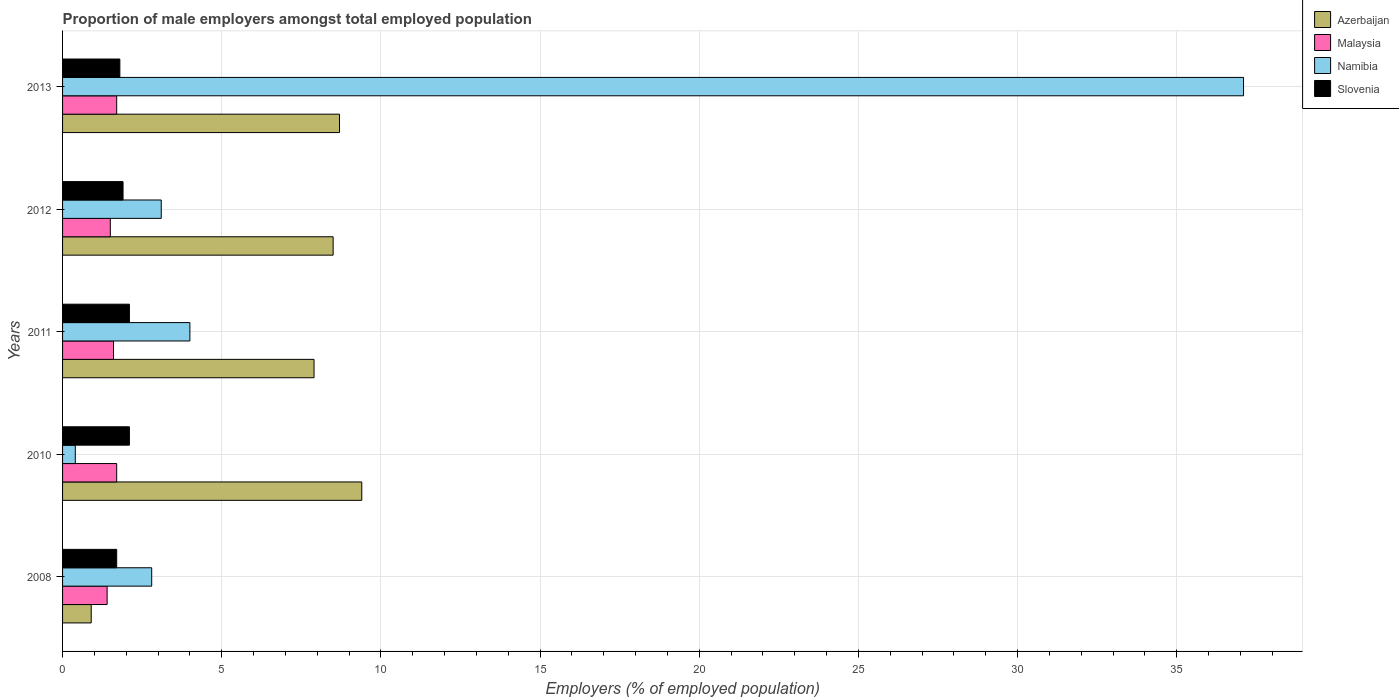How many different coloured bars are there?
Ensure brevity in your answer.  4. How many groups of bars are there?
Your response must be concise. 5. Are the number of bars per tick equal to the number of legend labels?
Give a very brief answer. Yes. How many bars are there on the 5th tick from the top?
Your answer should be very brief. 4. What is the label of the 3rd group of bars from the top?
Ensure brevity in your answer.  2011. Across all years, what is the maximum proportion of male employers in Azerbaijan?
Keep it short and to the point. 9.4. Across all years, what is the minimum proportion of male employers in Namibia?
Give a very brief answer. 0.4. In which year was the proportion of male employers in Malaysia minimum?
Offer a terse response. 2008. What is the total proportion of male employers in Azerbaijan in the graph?
Keep it short and to the point. 35.4. What is the difference between the proportion of male employers in Malaysia in 2012 and that in 2013?
Ensure brevity in your answer.  -0.2. What is the difference between the proportion of male employers in Namibia in 2010 and the proportion of male employers in Slovenia in 2008?
Offer a very short reply. -1.3. What is the average proportion of male employers in Slovenia per year?
Offer a very short reply. 1.92. In the year 2010, what is the difference between the proportion of male employers in Namibia and proportion of male employers in Slovenia?
Your answer should be compact. -1.7. In how many years, is the proportion of male employers in Slovenia greater than 17 %?
Ensure brevity in your answer.  0. What is the ratio of the proportion of male employers in Azerbaijan in 2011 to that in 2012?
Your response must be concise. 0.93. Is the proportion of male employers in Malaysia in 2010 less than that in 2013?
Your answer should be very brief. No. What is the difference between the highest and the second highest proportion of male employers in Slovenia?
Offer a very short reply. 0. What is the difference between the highest and the lowest proportion of male employers in Slovenia?
Your response must be concise. 0.4. In how many years, is the proportion of male employers in Azerbaijan greater than the average proportion of male employers in Azerbaijan taken over all years?
Give a very brief answer. 4. Is the sum of the proportion of male employers in Namibia in 2008 and 2013 greater than the maximum proportion of male employers in Azerbaijan across all years?
Offer a terse response. Yes. What does the 4th bar from the top in 2012 represents?
Offer a very short reply. Azerbaijan. What does the 4th bar from the bottom in 2013 represents?
Offer a terse response. Slovenia. Is it the case that in every year, the sum of the proportion of male employers in Slovenia and proportion of male employers in Azerbaijan is greater than the proportion of male employers in Malaysia?
Your answer should be very brief. Yes. How many bars are there?
Offer a very short reply. 20. Are all the bars in the graph horizontal?
Your response must be concise. Yes. How many years are there in the graph?
Provide a short and direct response. 5. Are the values on the major ticks of X-axis written in scientific E-notation?
Keep it short and to the point. No. Does the graph contain any zero values?
Offer a terse response. No. Does the graph contain grids?
Your answer should be compact. Yes. Where does the legend appear in the graph?
Offer a terse response. Top right. How many legend labels are there?
Offer a terse response. 4. How are the legend labels stacked?
Your response must be concise. Vertical. What is the title of the graph?
Make the answer very short. Proportion of male employers amongst total employed population. Does "Pakistan" appear as one of the legend labels in the graph?
Give a very brief answer. No. What is the label or title of the X-axis?
Your answer should be compact. Employers (% of employed population). What is the label or title of the Y-axis?
Provide a short and direct response. Years. What is the Employers (% of employed population) of Azerbaijan in 2008?
Ensure brevity in your answer.  0.9. What is the Employers (% of employed population) of Malaysia in 2008?
Offer a very short reply. 1.4. What is the Employers (% of employed population) of Namibia in 2008?
Offer a very short reply. 2.8. What is the Employers (% of employed population) of Slovenia in 2008?
Offer a terse response. 1.7. What is the Employers (% of employed population) of Azerbaijan in 2010?
Provide a succinct answer. 9.4. What is the Employers (% of employed population) of Malaysia in 2010?
Offer a very short reply. 1.7. What is the Employers (% of employed population) of Namibia in 2010?
Offer a very short reply. 0.4. What is the Employers (% of employed population) of Slovenia in 2010?
Your response must be concise. 2.1. What is the Employers (% of employed population) in Azerbaijan in 2011?
Provide a succinct answer. 7.9. What is the Employers (% of employed population) of Malaysia in 2011?
Give a very brief answer. 1.6. What is the Employers (% of employed population) in Slovenia in 2011?
Make the answer very short. 2.1. What is the Employers (% of employed population) in Malaysia in 2012?
Provide a succinct answer. 1.5. What is the Employers (% of employed population) in Namibia in 2012?
Offer a very short reply. 3.1. What is the Employers (% of employed population) in Slovenia in 2012?
Give a very brief answer. 1.9. What is the Employers (% of employed population) of Azerbaijan in 2013?
Offer a very short reply. 8.7. What is the Employers (% of employed population) of Malaysia in 2013?
Keep it short and to the point. 1.7. What is the Employers (% of employed population) of Namibia in 2013?
Ensure brevity in your answer.  37.1. What is the Employers (% of employed population) in Slovenia in 2013?
Your answer should be very brief. 1.8. Across all years, what is the maximum Employers (% of employed population) in Azerbaijan?
Offer a very short reply. 9.4. Across all years, what is the maximum Employers (% of employed population) of Malaysia?
Offer a very short reply. 1.7. Across all years, what is the maximum Employers (% of employed population) of Namibia?
Provide a short and direct response. 37.1. Across all years, what is the maximum Employers (% of employed population) of Slovenia?
Your answer should be very brief. 2.1. Across all years, what is the minimum Employers (% of employed population) in Azerbaijan?
Ensure brevity in your answer.  0.9. Across all years, what is the minimum Employers (% of employed population) in Malaysia?
Your answer should be compact. 1.4. Across all years, what is the minimum Employers (% of employed population) in Namibia?
Ensure brevity in your answer.  0.4. Across all years, what is the minimum Employers (% of employed population) in Slovenia?
Keep it short and to the point. 1.7. What is the total Employers (% of employed population) of Azerbaijan in the graph?
Make the answer very short. 35.4. What is the total Employers (% of employed population) in Namibia in the graph?
Your answer should be very brief. 47.4. What is the difference between the Employers (% of employed population) in Azerbaijan in 2008 and that in 2011?
Ensure brevity in your answer.  -7. What is the difference between the Employers (% of employed population) in Namibia in 2008 and that in 2011?
Your response must be concise. -1.2. What is the difference between the Employers (% of employed population) in Namibia in 2008 and that in 2012?
Provide a succinct answer. -0.3. What is the difference between the Employers (% of employed population) of Azerbaijan in 2008 and that in 2013?
Your answer should be very brief. -7.8. What is the difference between the Employers (% of employed population) of Namibia in 2008 and that in 2013?
Make the answer very short. -34.3. What is the difference between the Employers (% of employed population) in Azerbaijan in 2010 and that in 2011?
Offer a very short reply. 1.5. What is the difference between the Employers (% of employed population) of Malaysia in 2010 and that in 2011?
Give a very brief answer. 0.1. What is the difference between the Employers (% of employed population) of Namibia in 2010 and that in 2011?
Provide a short and direct response. -3.6. What is the difference between the Employers (% of employed population) of Malaysia in 2010 and that in 2012?
Provide a succinct answer. 0.2. What is the difference between the Employers (% of employed population) in Slovenia in 2010 and that in 2012?
Give a very brief answer. 0.2. What is the difference between the Employers (% of employed population) in Azerbaijan in 2010 and that in 2013?
Keep it short and to the point. 0.7. What is the difference between the Employers (% of employed population) of Namibia in 2010 and that in 2013?
Provide a short and direct response. -36.7. What is the difference between the Employers (% of employed population) in Slovenia in 2010 and that in 2013?
Provide a succinct answer. 0.3. What is the difference between the Employers (% of employed population) of Azerbaijan in 2011 and that in 2012?
Ensure brevity in your answer.  -0.6. What is the difference between the Employers (% of employed population) of Malaysia in 2011 and that in 2012?
Your response must be concise. 0.1. What is the difference between the Employers (% of employed population) in Malaysia in 2011 and that in 2013?
Your answer should be very brief. -0.1. What is the difference between the Employers (% of employed population) of Namibia in 2011 and that in 2013?
Keep it short and to the point. -33.1. What is the difference between the Employers (% of employed population) of Slovenia in 2011 and that in 2013?
Give a very brief answer. 0.3. What is the difference between the Employers (% of employed population) of Azerbaijan in 2012 and that in 2013?
Provide a succinct answer. -0.2. What is the difference between the Employers (% of employed population) in Namibia in 2012 and that in 2013?
Offer a very short reply. -34. What is the difference between the Employers (% of employed population) of Azerbaijan in 2008 and the Employers (% of employed population) of Malaysia in 2010?
Offer a very short reply. -0.8. What is the difference between the Employers (% of employed population) of Azerbaijan in 2008 and the Employers (% of employed population) of Namibia in 2010?
Offer a terse response. 0.5. What is the difference between the Employers (% of employed population) of Azerbaijan in 2008 and the Employers (% of employed population) of Slovenia in 2010?
Your response must be concise. -1.2. What is the difference between the Employers (% of employed population) in Malaysia in 2008 and the Employers (% of employed population) in Slovenia in 2010?
Offer a very short reply. -0.7. What is the difference between the Employers (% of employed population) in Azerbaijan in 2008 and the Employers (% of employed population) in Namibia in 2011?
Make the answer very short. -3.1. What is the difference between the Employers (% of employed population) in Azerbaijan in 2008 and the Employers (% of employed population) in Slovenia in 2011?
Ensure brevity in your answer.  -1.2. What is the difference between the Employers (% of employed population) of Malaysia in 2008 and the Employers (% of employed population) of Namibia in 2011?
Make the answer very short. -2.6. What is the difference between the Employers (% of employed population) in Namibia in 2008 and the Employers (% of employed population) in Slovenia in 2011?
Provide a short and direct response. 0.7. What is the difference between the Employers (% of employed population) of Azerbaijan in 2008 and the Employers (% of employed population) of Namibia in 2012?
Provide a short and direct response. -2.2. What is the difference between the Employers (% of employed population) in Malaysia in 2008 and the Employers (% of employed population) in Slovenia in 2012?
Your response must be concise. -0.5. What is the difference between the Employers (% of employed population) in Azerbaijan in 2008 and the Employers (% of employed population) in Malaysia in 2013?
Ensure brevity in your answer.  -0.8. What is the difference between the Employers (% of employed population) of Azerbaijan in 2008 and the Employers (% of employed population) of Namibia in 2013?
Your response must be concise. -36.2. What is the difference between the Employers (% of employed population) in Malaysia in 2008 and the Employers (% of employed population) in Namibia in 2013?
Your answer should be compact. -35.7. What is the difference between the Employers (% of employed population) in Namibia in 2008 and the Employers (% of employed population) in Slovenia in 2013?
Provide a short and direct response. 1. What is the difference between the Employers (% of employed population) of Azerbaijan in 2010 and the Employers (% of employed population) of Malaysia in 2011?
Your answer should be very brief. 7.8. What is the difference between the Employers (% of employed population) of Azerbaijan in 2010 and the Employers (% of employed population) of Namibia in 2011?
Offer a terse response. 5.4. What is the difference between the Employers (% of employed population) in Azerbaijan in 2010 and the Employers (% of employed population) in Slovenia in 2011?
Keep it short and to the point. 7.3. What is the difference between the Employers (% of employed population) in Namibia in 2010 and the Employers (% of employed population) in Slovenia in 2011?
Your response must be concise. -1.7. What is the difference between the Employers (% of employed population) of Azerbaijan in 2010 and the Employers (% of employed population) of Namibia in 2012?
Your answer should be compact. 6.3. What is the difference between the Employers (% of employed population) of Malaysia in 2010 and the Employers (% of employed population) of Namibia in 2012?
Make the answer very short. -1.4. What is the difference between the Employers (% of employed population) in Malaysia in 2010 and the Employers (% of employed population) in Slovenia in 2012?
Make the answer very short. -0.2. What is the difference between the Employers (% of employed population) in Azerbaijan in 2010 and the Employers (% of employed population) in Namibia in 2013?
Ensure brevity in your answer.  -27.7. What is the difference between the Employers (% of employed population) of Malaysia in 2010 and the Employers (% of employed population) of Namibia in 2013?
Give a very brief answer. -35.4. What is the difference between the Employers (% of employed population) of Malaysia in 2010 and the Employers (% of employed population) of Slovenia in 2013?
Offer a very short reply. -0.1. What is the difference between the Employers (% of employed population) in Azerbaijan in 2011 and the Employers (% of employed population) in Malaysia in 2012?
Offer a very short reply. 6.4. What is the difference between the Employers (% of employed population) in Azerbaijan in 2011 and the Employers (% of employed population) in Namibia in 2012?
Make the answer very short. 4.8. What is the difference between the Employers (% of employed population) of Azerbaijan in 2011 and the Employers (% of employed population) of Slovenia in 2012?
Provide a succinct answer. 6. What is the difference between the Employers (% of employed population) in Malaysia in 2011 and the Employers (% of employed population) in Namibia in 2012?
Keep it short and to the point. -1.5. What is the difference between the Employers (% of employed population) of Malaysia in 2011 and the Employers (% of employed population) of Slovenia in 2012?
Your answer should be very brief. -0.3. What is the difference between the Employers (% of employed population) of Namibia in 2011 and the Employers (% of employed population) of Slovenia in 2012?
Make the answer very short. 2.1. What is the difference between the Employers (% of employed population) of Azerbaijan in 2011 and the Employers (% of employed population) of Malaysia in 2013?
Make the answer very short. 6.2. What is the difference between the Employers (% of employed population) in Azerbaijan in 2011 and the Employers (% of employed population) in Namibia in 2013?
Provide a short and direct response. -29.2. What is the difference between the Employers (% of employed population) in Malaysia in 2011 and the Employers (% of employed population) in Namibia in 2013?
Offer a terse response. -35.5. What is the difference between the Employers (% of employed population) of Namibia in 2011 and the Employers (% of employed population) of Slovenia in 2013?
Give a very brief answer. 2.2. What is the difference between the Employers (% of employed population) of Azerbaijan in 2012 and the Employers (% of employed population) of Namibia in 2013?
Ensure brevity in your answer.  -28.6. What is the difference between the Employers (% of employed population) in Malaysia in 2012 and the Employers (% of employed population) in Namibia in 2013?
Your response must be concise. -35.6. What is the average Employers (% of employed population) in Azerbaijan per year?
Your answer should be compact. 7.08. What is the average Employers (% of employed population) in Malaysia per year?
Your response must be concise. 1.58. What is the average Employers (% of employed population) in Namibia per year?
Give a very brief answer. 9.48. What is the average Employers (% of employed population) of Slovenia per year?
Ensure brevity in your answer.  1.92. In the year 2008, what is the difference between the Employers (% of employed population) of Azerbaijan and Employers (% of employed population) of Malaysia?
Keep it short and to the point. -0.5. In the year 2008, what is the difference between the Employers (% of employed population) of Namibia and Employers (% of employed population) of Slovenia?
Keep it short and to the point. 1.1. In the year 2010, what is the difference between the Employers (% of employed population) of Azerbaijan and Employers (% of employed population) of Malaysia?
Keep it short and to the point. 7.7. In the year 2010, what is the difference between the Employers (% of employed population) in Azerbaijan and Employers (% of employed population) in Slovenia?
Ensure brevity in your answer.  7.3. In the year 2010, what is the difference between the Employers (% of employed population) of Malaysia and Employers (% of employed population) of Slovenia?
Keep it short and to the point. -0.4. In the year 2012, what is the difference between the Employers (% of employed population) in Azerbaijan and Employers (% of employed population) in Malaysia?
Your answer should be compact. 7. In the year 2012, what is the difference between the Employers (% of employed population) in Azerbaijan and Employers (% of employed population) in Slovenia?
Keep it short and to the point. 6.6. In the year 2012, what is the difference between the Employers (% of employed population) of Malaysia and Employers (% of employed population) of Slovenia?
Offer a very short reply. -0.4. In the year 2012, what is the difference between the Employers (% of employed population) of Namibia and Employers (% of employed population) of Slovenia?
Provide a succinct answer. 1.2. In the year 2013, what is the difference between the Employers (% of employed population) of Azerbaijan and Employers (% of employed population) of Malaysia?
Make the answer very short. 7. In the year 2013, what is the difference between the Employers (% of employed population) in Azerbaijan and Employers (% of employed population) in Namibia?
Provide a succinct answer. -28.4. In the year 2013, what is the difference between the Employers (% of employed population) in Azerbaijan and Employers (% of employed population) in Slovenia?
Keep it short and to the point. 6.9. In the year 2013, what is the difference between the Employers (% of employed population) in Malaysia and Employers (% of employed population) in Namibia?
Give a very brief answer. -35.4. In the year 2013, what is the difference between the Employers (% of employed population) in Namibia and Employers (% of employed population) in Slovenia?
Your response must be concise. 35.3. What is the ratio of the Employers (% of employed population) of Azerbaijan in 2008 to that in 2010?
Provide a short and direct response. 0.1. What is the ratio of the Employers (% of employed population) of Malaysia in 2008 to that in 2010?
Your answer should be compact. 0.82. What is the ratio of the Employers (% of employed population) of Namibia in 2008 to that in 2010?
Provide a short and direct response. 7. What is the ratio of the Employers (% of employed population) of Slovenia in 2008 to that in 2010?
Your answer should be very brief. 0.81. What is the ratio of the Employers (% of employed population) of Azerbaijan in 2008 to that in 2011?
Give a very brief answer. 0.11. What is the ratio of the Employers (% of employed population) of Namibia in 2008 to that in 2011?
Your response must be concise. 0.7. What is the ratio of the Employers (% of employed population) of Slovenia in 2008 to that in 2011?
Make the answer very short. 0.81. What is the ratio of the Employers (% of employed population) of Azerbaijan in 2008 to that in 2012?
Ensure brevity in your answer.  0.11. What is the ratio of the Employers (% of employed population) of Namibia in 2008 to that in 2012?
Offer a very short reply. 0.9. What is the ratio of the Employers (% of employed population) in Slovenia in 2008 to that in 2012?
Ensure brevity in your answer.  0.89. What is the ratio of the Employers (% of employed population) in Azerbaijan in 2008 to that in 2013?
Offer a terse response. 0.1. What is the ratio of the Employers (% of employed population) in Malaysia in 2008 to that in 2013?
Your response must be concise. 0.82. What is the ratio of the Employers (% of employed population) of Namibia in 2008 to that in 2013?
Make the answer very short. 0.08. What is the ratio of the Employers (% of employed population) in Azerbaijan in 2010 to that in 2011?
Ensure brevity in your answer.  1.19. What is the ratio of the Employers (% of employed population) of Malaysia in 2010 to that in 2011?
Your response must be concise. 1.06. What is the ratio of the Employers (% of employed population) in Slovenia in 2010 to that in 2011?
Make the answer very short. 1. What is the ratio of the Employers (% of employed population) of Azerbaijan in 2010 to that in 2012?
Give a very brief answer. 1.11. What is the ratio of the Employers (% of employed population) of Malaysia in 2010 to that in 2012?
Offer a very short reply. 1.13. What is the ratio of the Employers (% of employed population) in Namibia in 2010 to that in 2012?
Offer a very short reply. 0.13. What is the ratio of the Employers (% of employed population) of Slovenia in 2010 to that in 2012?
Give a very brief answer. 1.11. What is the ratio of the Employers (% of employed population) in Azerbaijan in 2010 to that in 2013?
Your answer should be compact. 1.08. What is the ratio of the Employers (% of employed population) of Malaysia in 2010 to that in 2013?
Your response must be concise. 1. What is the ratio of the Employers (% of employed population) in Namibia in 2010 to that in 2013?
Offer a very short reply. 0.01. What is the ratio of the Employers (% of employed population) in Slovenia in 2010 to that in 2013?
Give a very brief answer. 1.17. What is the ratio of the Employers (% of employed population) of Azerbaijan in 2011 to that in 2012?
Offer a terse response. 0.93. What is the ratio of the Employers (% of employed population) of Malaysia in 2011 to that in 2012?
Your answer should be compact. 1.07. What is the ratio of the Employers (% of employed population) of Namibia in 2011 to that in 2012?
Provide a short and direct response. 1.29. What is the ratio of the Employers (% of employed population) in Slovenia in 2011 to that in 2012?
Your answer should be very brief. 1.11. What is the ratio of the Employers (% of employed population) in Azerbaijan in 2011 to that in 2013?
Provide a succinct answer. 0.91. What is the ratio of the Employers (% of employed population) in Malaysia in 2011 to that in 2013?
Provide a short and direct response. 0.94. What is the ratio of the Employers (% of employed population) in Namibia in 2011 to that in 2013?
Make the answer very short. 0.11. What is the ratio of the Employers (% of employed population) in Malaysia in 2012 to that in 2013?
Your answer should be compact. 0.88. What is the ratio of the Employers (% of employed population) of Namibia in 2012 to that in 2013?
Your answer should be compact. 0.08. What is the ratio of the Employers (% of employed population) of Slovenia in 2012 to that in 2013?
Give a very brief answer. 1.06. What is the difference between the highest and the second highest Employers (% of employed population) of Azerbaijan?
Your answer should be very brief. 0.7. What is the difference between the highest and the second highest Employers (% of employed population) in Namibia?
Your answer should be very brief. 33.1. What is the difference between the highest and the lowest Employers (% of employed population) of Azerbaijan?
Your answer should be compact. 8.5. What is the difference between the highest and the lowest Employers (% of employed population) in Malaysia?
Ensure brevity in your answer.  0.3. What is the difference between the highest and the lowest Employers (% of employed population) of Namibia?
Offer a terse response. 36.7. 